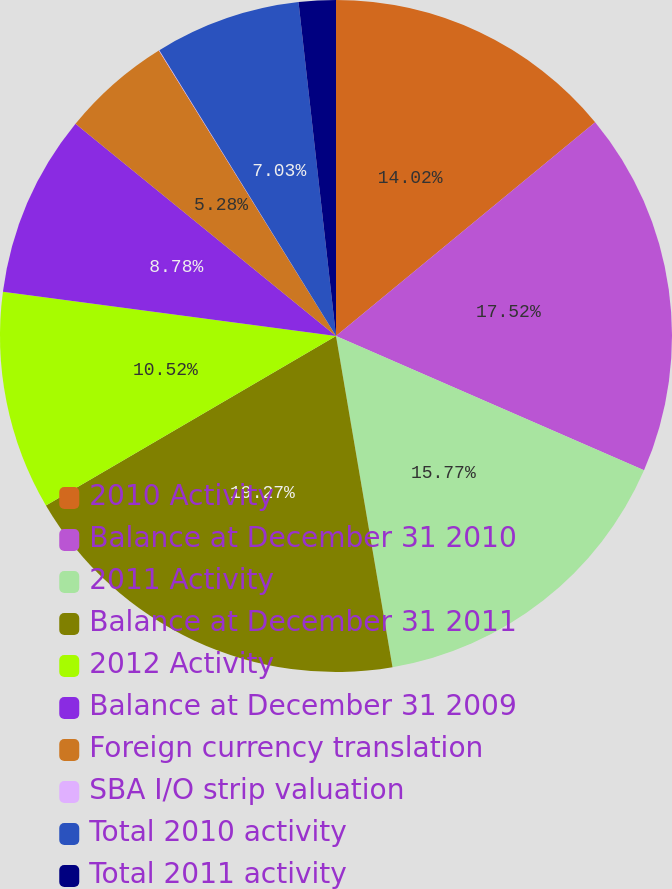Convert chart to OTSL. <chart><loc_0><loc_0><loc_500><loc_500><pie_chart><fcel>2010 Activity<fcel>Balance at December 31 2010<fcel>2011 Activity<fcel>Balance at December 31 2011<fcel>2012 Activity<fcel>Balance at December 31 2009<fcel>Foreign currency translation<fcel>SBA I/O strip valuation<fcel>Total 2010 activity<fcel>Total 2011 activity<nl><fcel>14.02%<fcel>17.52%<fcel>15.77%<fcel>19.27%<fcel>10.52%<fcel>8.78%<fcel>5.28%<fcel>0.03%<fcel>7.03%<fcel>1.78%<nl></chart> 